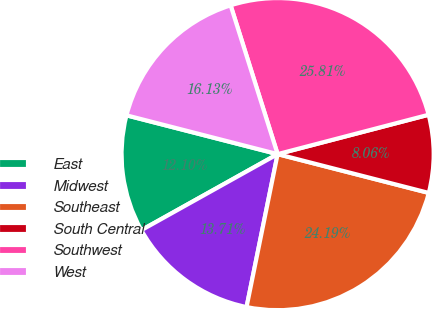<chart> <loc_0><loc_0><loc_500><loc_500><pie_chart><fcel>East<fcel>Midwest<fcel>Southeast<fcel>South Central<fcel>Southwest<fcel>West<nl><fcel>12.1%<fcel>13.71%<fcel>24.19%<fcel>8.06%<fcel>25.81%<fcel>16.13%<nl></chart> 